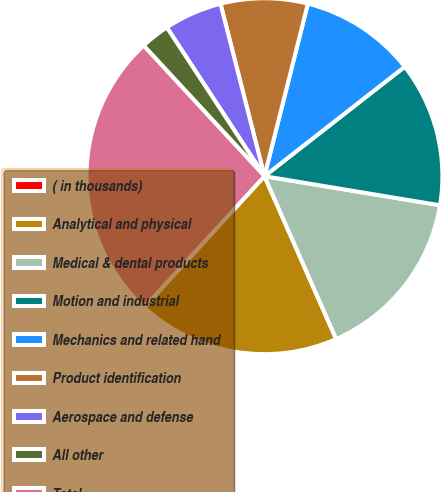<chart> <loc_0><loc_0><loc_500><loc_500><pie_chart><fcel>( in thousands)<fcel>Analytical and physical<fcel>Medical & dental products<fcel>Motion and industrial<fcel>Mechanics and related hand<fcel>Product identification<fcel>Aerospace and defense<fcel>All other<fcel>Total<nl><fcel>0.0%<fcel>18.42%<fcel>15.79%<fcel>13.16%<fcel>10.53%<fcel>7.9%<fcel>5.27%<fcel>2.64%<fcel>26.31%<nl></chart> 